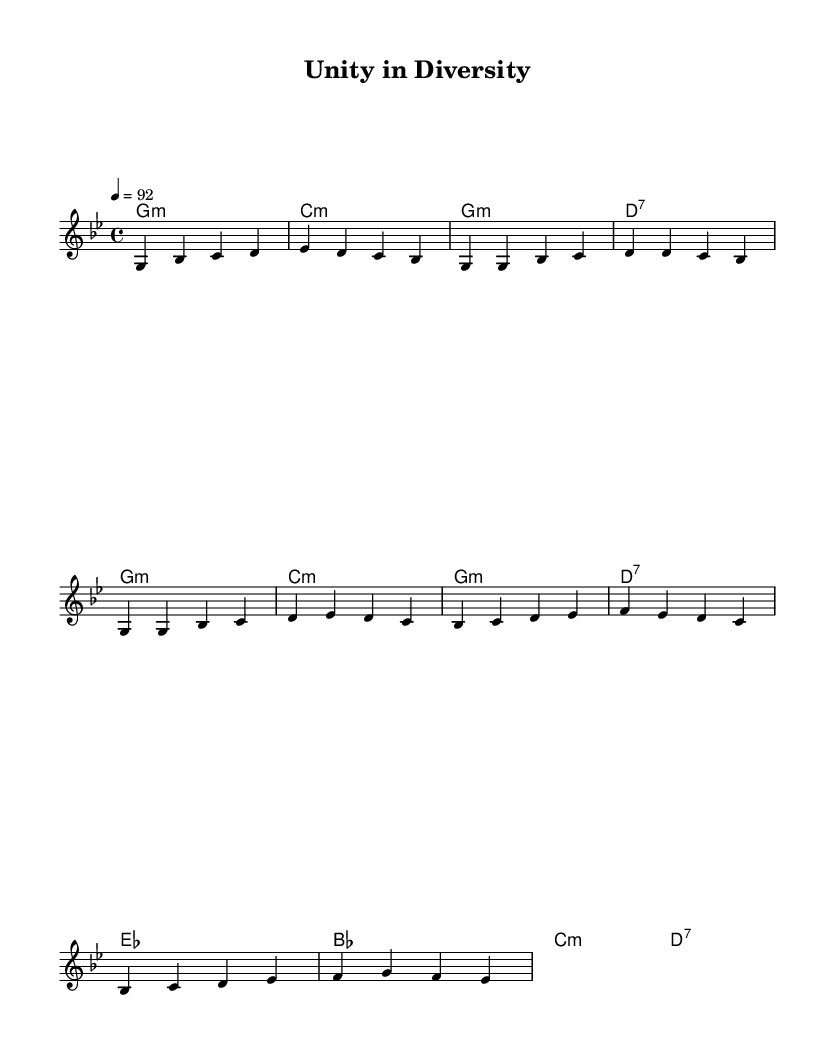What is the key signature of this music? The key signature indicates that the music is in G minor, which has two flats (B♭ and E♭). This can be determined by analyzing the key signature displayed at the beginning of the sheet music.
Answer: G minor What is the time signature of this piece? The time signature is 4/4, which is indicated at the beginning of the piece. This means there are four beats in each measure, and the quarter note gets one beat.
Answer: 4/4 What is the tempo of the music? The tempo marking is 92 BPM (beats per minute), which is indicated at the beginning of the score. This tells performers to play at a moderate speed.
Answer: 92 How many measures are in the intro section? The intro section consists of 2 measures. This is determined by counting the individual groupings of notes written before the verse starts.
Answer: 2 What type of chord is used at the beginning of the piece? The first chord is a G minor chord, which can be identified by reading the chord symbols listed above the melody. The symbol "g:m" indicates it is a minor chord.
Answer: G minor What is the overall theme conveyed in the chorus? The chorus emphasizes unity through diversity, highlighting the importance of interfaith dialogue. While this is more thematic than structural, it reflects the focus of the piece's lyrics.
Answer: Unity in diversity How does the harmonic progression change from the verse to the chorus? In the verse, the harmony predominantly alternates between G minor and C minor, while in the chorus, it shifts to E♭ major and B♭ major, indicating a movement towards a more uplifting sound. This requires comparing the chord changes in both sections.
Answer: Changes from minor to major chords 